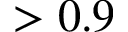<formula> <loc_0><loc_0><loc_500><loc_500>> 0 . 9</formula> 